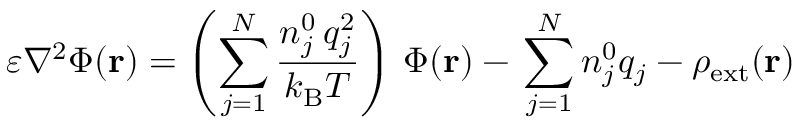Convert formula to latex. <formula><loc_0><loc_0><loc_500><loc_500>\varepsilon \nabla ^ { 2 } \Phi ( r ) = \left ( \sum _ { j = 1 } ^ { N } { \frac { n _ { j } ^ { 0 } \, q _ { j } ^ { 2 } } { k _ { B } T } } \right ) \, \Phi ( r ) - \, \sum _ { j = 1 } ^ { N } n _ { j } ^ { 0 } q _ { j } - \rho _ { e x t } ( r )</formula> 